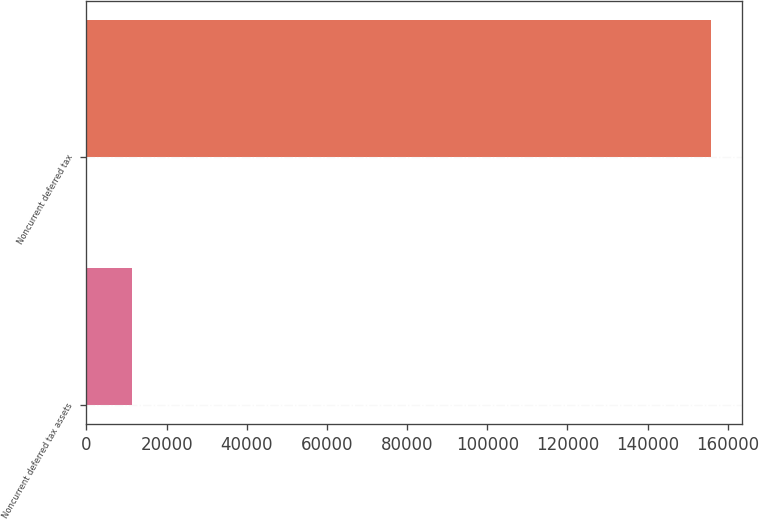Convert chart to OTSL. <chart><loc_0><loc_0><loc_500><loc_500><bar_chart><fcel>Noncurrent deferred tax assets<fcel>Noncurrent deferred tax<nl><fcel>11422<fcel>155728<nl></chart> 